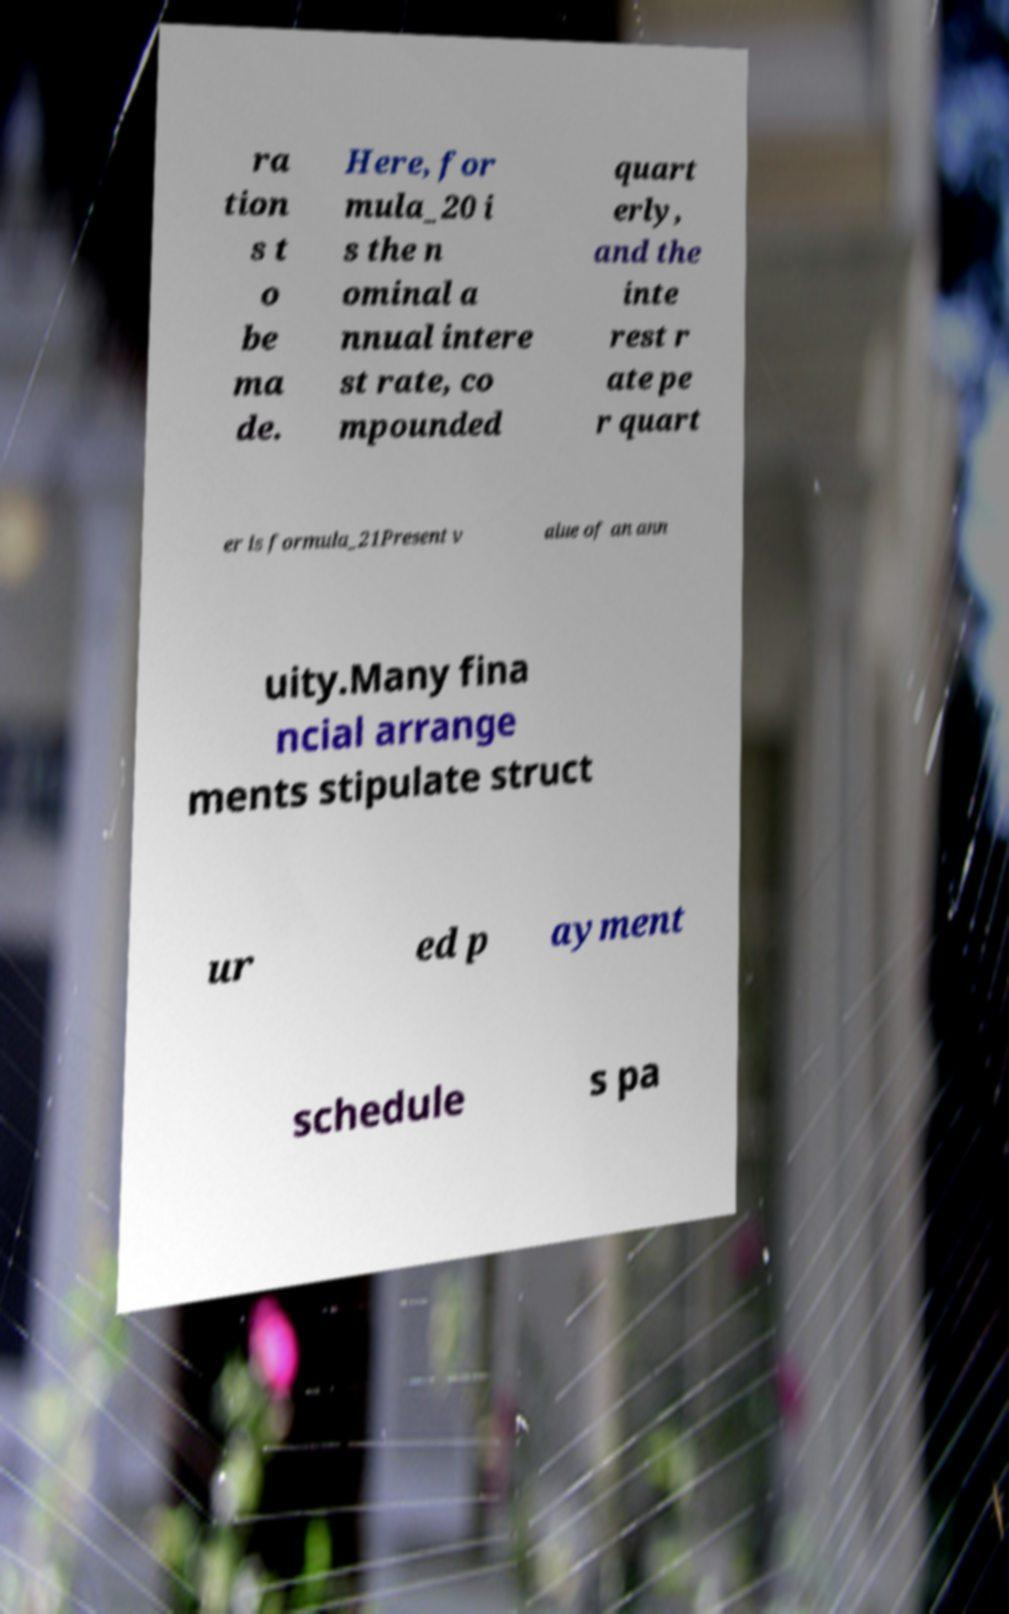Please identify and transcribe the text found in this image. ra tion s t o be ma de. Here, for mula_20 i s the n ominal a nnual intere st rate, co mpounded quart erly, and the inte rest r ate pe r quart er is formula_21Present v alue of an ann uity.Many fina ncial arrange ments stipulate struct ur ed p ayment schedule s pa 